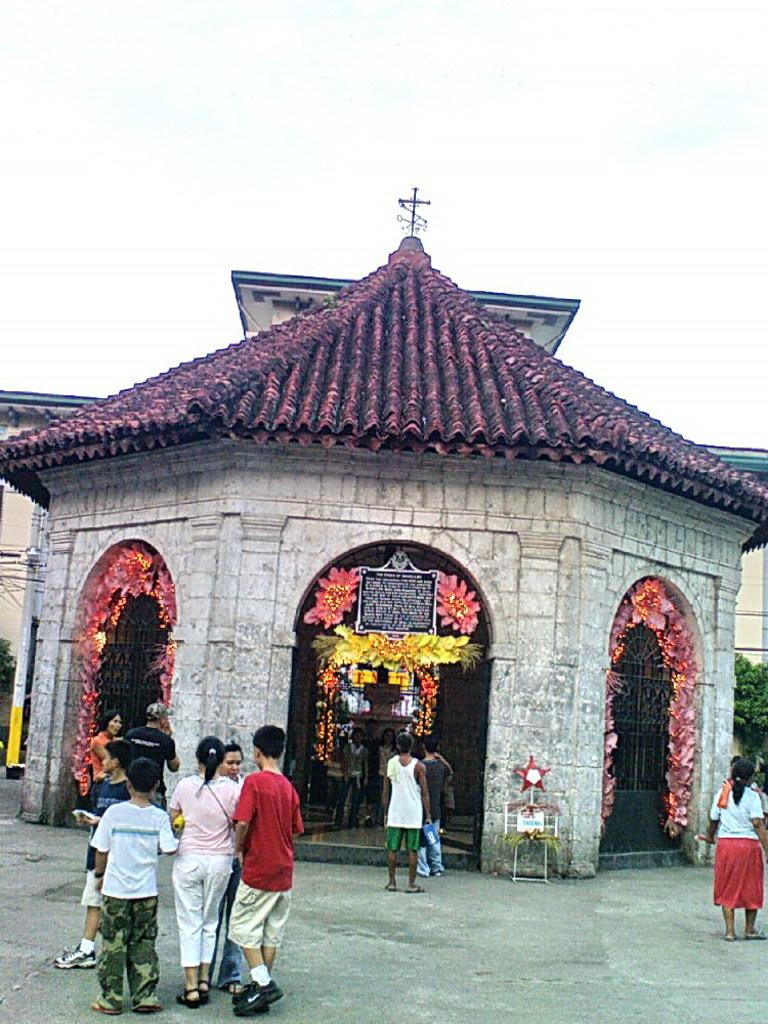How many people are in the image? There is a group of people in the image, but the exact number is not specified. What is located in front of the group of people? There are buildings in front of the group of people. What type of vegetation can be seen in the image? Flowers and trees are visible in the image. What else can be seen in the image besides the people and vegetation? Poles are in the image. What type of appliance is being used by the people in the image? There is no appliance visible in the image. What game are the people playing in the image? There is no game being played in the image. 